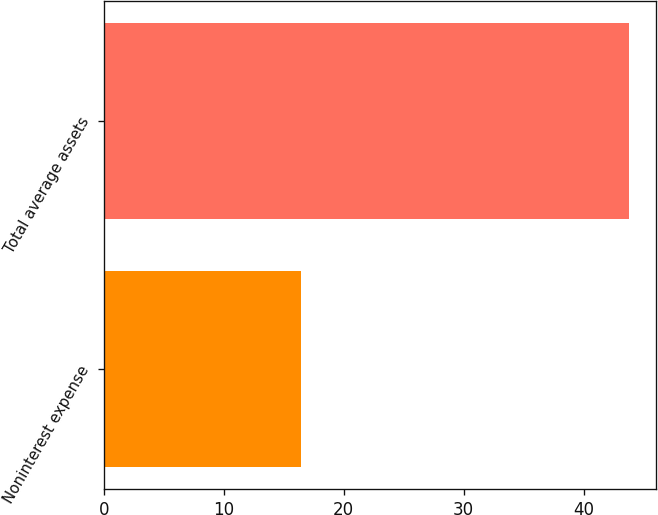Convert chart to OTSL. <chart><loc_0><loc_0><loc_500><loc_500><bar_chart><fcel>Noninterest expense<fcel>Total average assets<nl><fcel>16.4<fcel>43.8<nl></chart> 